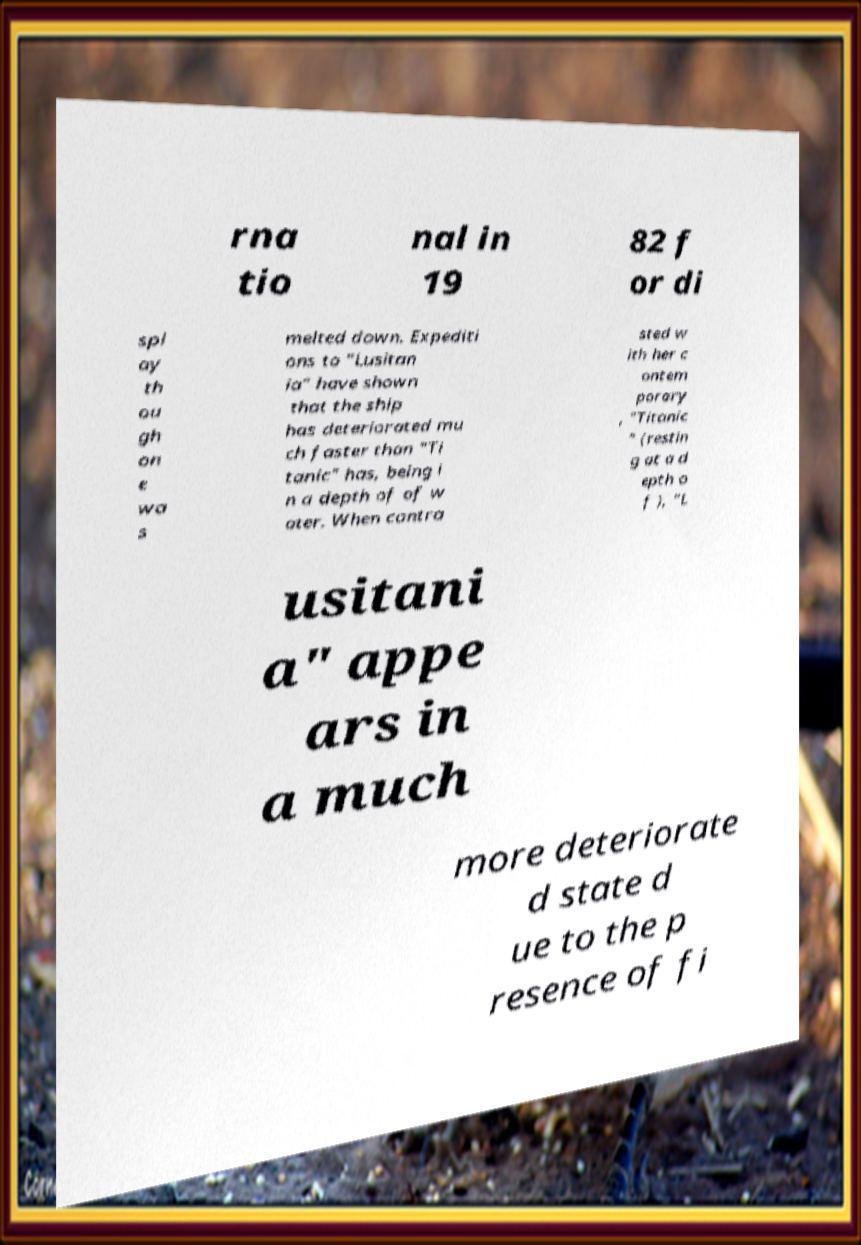Please identify and transcribe the text found in this image. rna tio nal in 19 82 f or di spl ay th ou gh on e wa s melted down. Expediti ons to "Lusitan ia" have shown that the ship has deteriorated mu ch faster than "Ti tanic" has, being i n a depth of of w ater. When contra sted w ith her c ontem porary , "Titanic " (restin g at a d epth o f ), "L usitani a" appe ars in a much more deteriorate d state d ue to the p resence of fi 